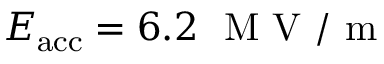Convert formula to latex. <formula><loc_0><loc_0><loc_500><loc_500>E _ { a c c } = 6 . 2 \ M V / m</formula> 